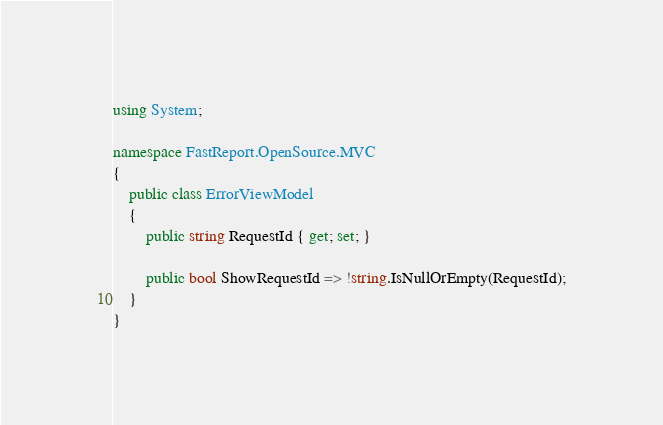<code> <loc_0><loc_0><loc_500><loc_500><_C#_>using System;

namespace FastReport.OpenSource.MVC
{
    public class ErrorViewModel
    {
        public string RequestId { get; set; }

        public bool ShowRequestId => !string.IsNullOrEmpty(RequestId);
    }
}</code> 